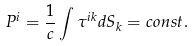Convert formula to latex. <formula><loc_0><loc_0><loc_500><loc_500>P ^ { i } = \frac { 1 } { c } \int \tau ^ { i k } d S _ { k } = c o n s t .</formula> 